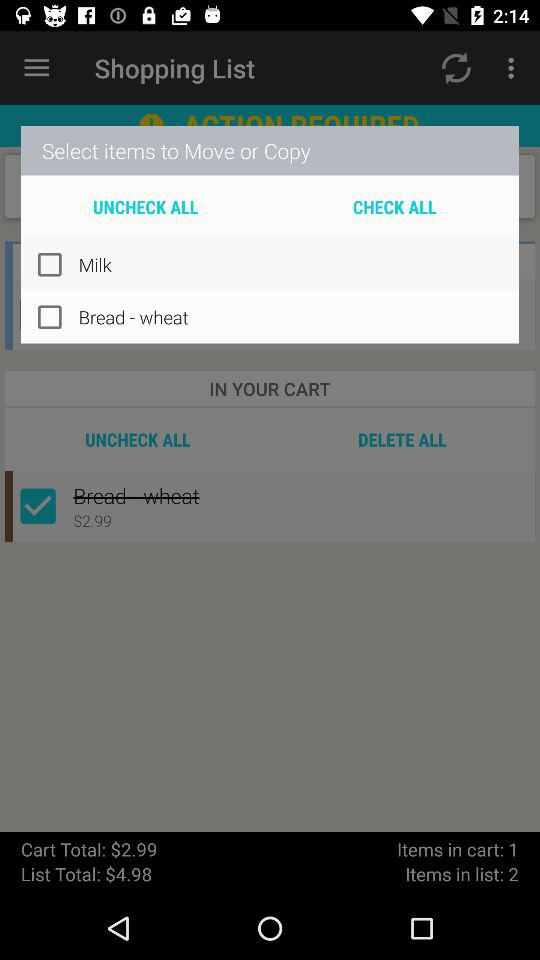What is the number of items in the cart? The number of items in the cart is 1. 